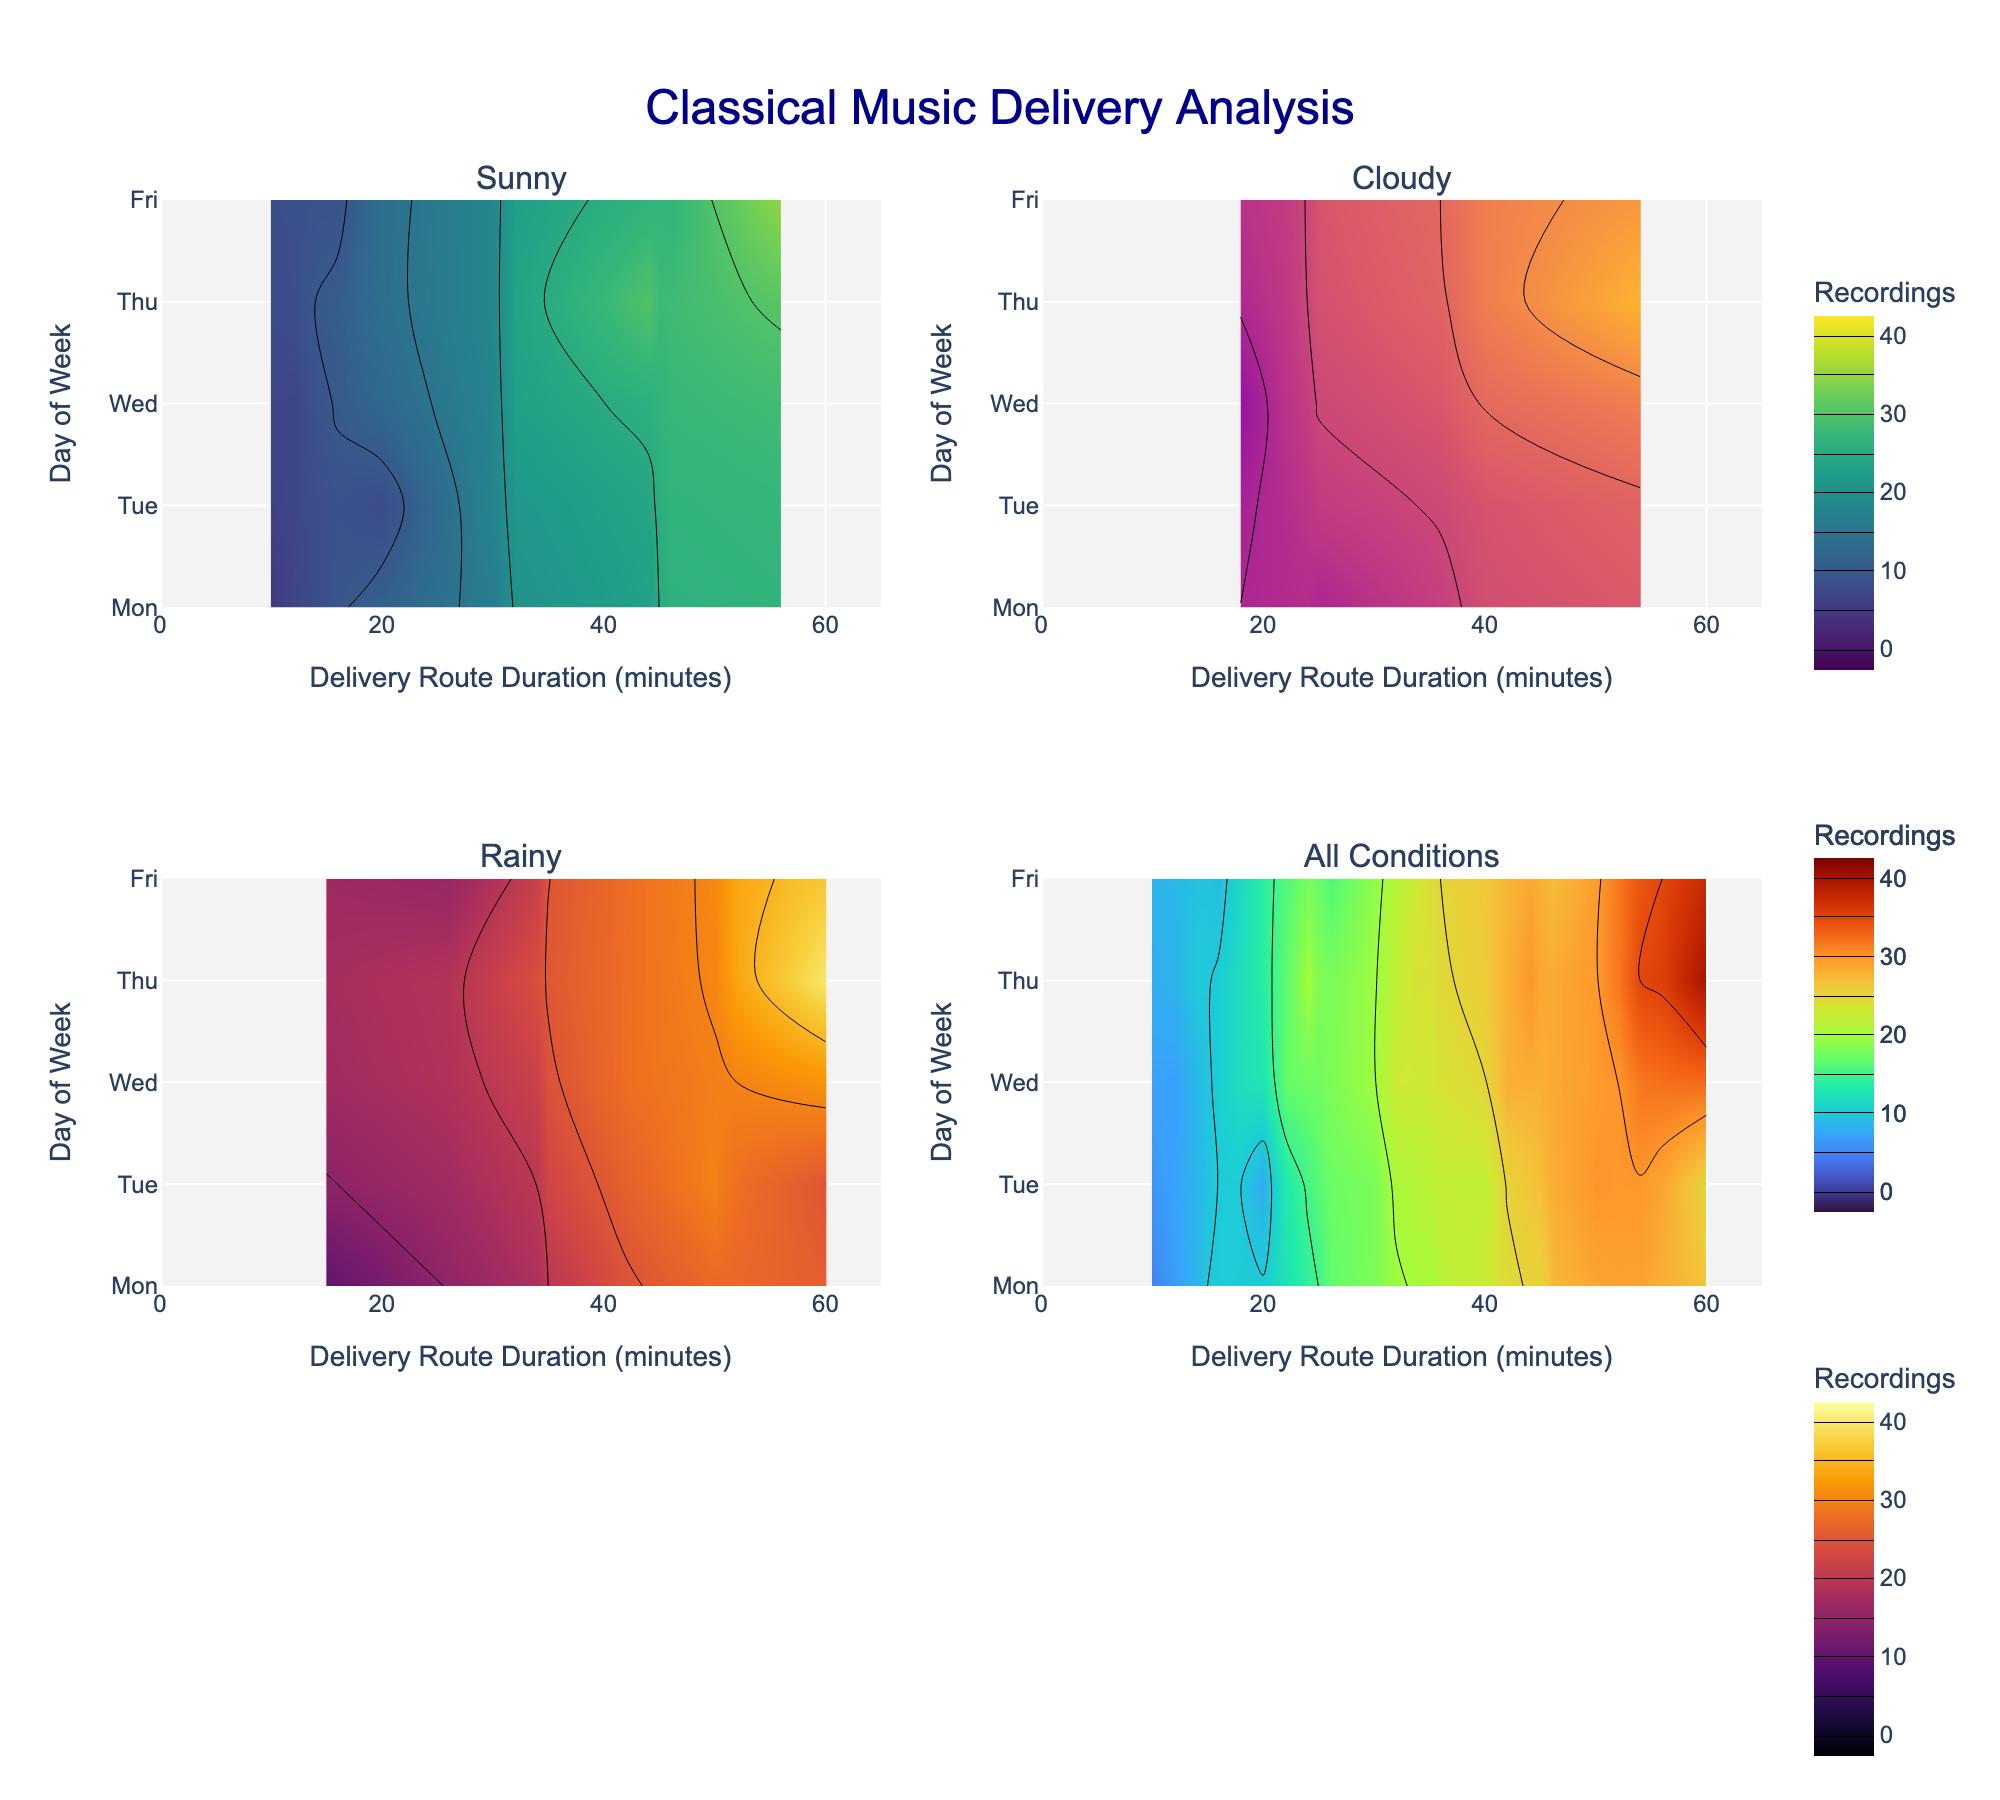What's the title of the plot? The title is prominently displayed at the top of the plot. It reads "Classical Music Delivery Analysis".
Answer: Classical Music Delivery Analysis What are the x-axis and y-axis titles? The x-axis is labeled "Delivery Route Duration (minutes)", and the y-axis is titled "Day of Week", which can be seen at the bottom and left side of the plots respectively.
Answer: x-axis: Delivery Route Duration (minutes), y-axis: Day of Week Which day of the week has data points for the 'Sunny' weather condition in the first subplot? For the 'Sunny' weather condition in the first subplot, you can see data points most prominently on Monday, Tuesday, Wednesday, Thursday, and Friday as indicated by the ticks on the y-axis.
Answer: Monday, Tuesday, Wednesday, Thursday, Friday In the 'Cloudy' subplot, on which day does the maximum number of recordings occur? By observing the 'Cloudy' subplot, the contour lines indicate the maximum number of recordings on Thursday where the contours are dense with high values.
Answer: Thursday Which subplot shows the overall data including all weather conditions? The subplot in the bottom-right corner (row 2, column 2) is designated for 'All Conditions', combining data across all weather conditions.
Answer: Bottom-right subplot (All Conditions) Compare the 'Sunny' and 'Rainy' subplots: Which weather condition has higher delivery route durations for a similar number of recordings on average? By examining the contour lines and color levels, it is noticeable that 'Rainy' conditions generally have higher delivery route durations compared to 'Sunny' conditions for the same number of recordings. For example, the 'Rainy' subplot shows high route durations around 35-50 minutes for higher recordings, while 'Sunny' shows similar recording numbers at lower durations (around 10-30 minutes).
Answer: Rainy What is the color scale used for the 'Rainy' subplot? The 'Rainy' subplot uses the 'Inferno' color scale, as indicated by the color variation and the provided information.
Answer: Inferno Which day had the maximum number of recordings across all conditions? In the 'All Conditions' subplot, Thursday shows a contour area with the highest number of recordings, significantly indicated with the brightest coloration and dense lines.
Answer: Thursday Do higher numbers of delivered recordings correlate with longer delivery route durations? Observing the general trend in the 'All Conditions' subplot, there's a noticeable pattern where higher numbers of recordings are associated with longer delivery route durations, indicated by the extended contour lines towards higher delivery times.
Answer: Yes 